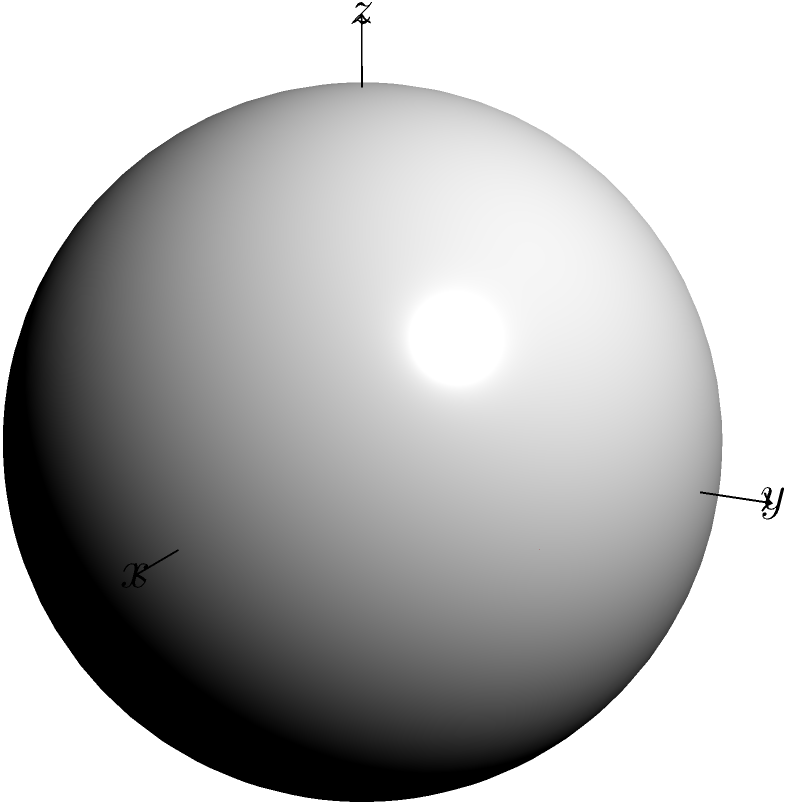In quantum computing, the Bloch sphere is used to represent qubit states. Given the Bloch sphere representation shown, where the red arrow represents a qubit state, determine the state vector $|\psi\rangle$ in terms of $|0\rangle$ and $|1\rangle$ basis states. Assume the z-axis represents the computational basis, and the angles $\theta$ and $\phi$ are as labeled in the diagram. To determine the state vector $|\psi\rangle$, we'll follow these steps:

1. Recall the general form of a qubit state on the Bloch sphere:
   $|\psi\rangle = \cos(\frac{\theta}{2})|0\rangle + e^{i\phi}\sin(\frac{\theta}{2})|1\rangle$

2. From the diagram, we can see that:
   - $\theta \approx \frac{\pi}{2}$ (the angle from the z-axis)
   - $\phi \approx \frac{\pi}{4}$ (the angle in the x-y plane from the x-axis)

3. Substituting these values:
   $|\psi\rangle = \cos(\frac{\pi}{4})|0\rangle + e^{i\frac{\pi}{4}}\sin(\frac{\pi}{4})|1\rangle$

4. Simplify:
   $\cos(\frac{\pi}{4}) = \sin(\frac{\pi}{4}) = \frac{1}{\sqrt{2}}$
   $e^{i\frac{\pi}{4}} = \frac{1}{\sqrt{2}}(1+i)$

5. Therefore:
   $|\psi\rangle = \frac{1}{\sqrt{2}}|0\rangle + \frac{1}{\sqrt{2}}\frac{1}{\sqrt{2}}(1+i)|1\rangle$

6. Simplify further:
   $|\psi\rangle = \frac{1}{\sqrt{2}}|0\rangle + \frac{1}{2}(1+i)|1\rangle$

This state vector represents the qubit state shown by the red arrow on the Bloch sphere.
Answer: $|\psi\rangle = \frac{1}{\sqrt{2}}|0\rangle + \frac{1}{2}(1+i)|1\rangle$ 